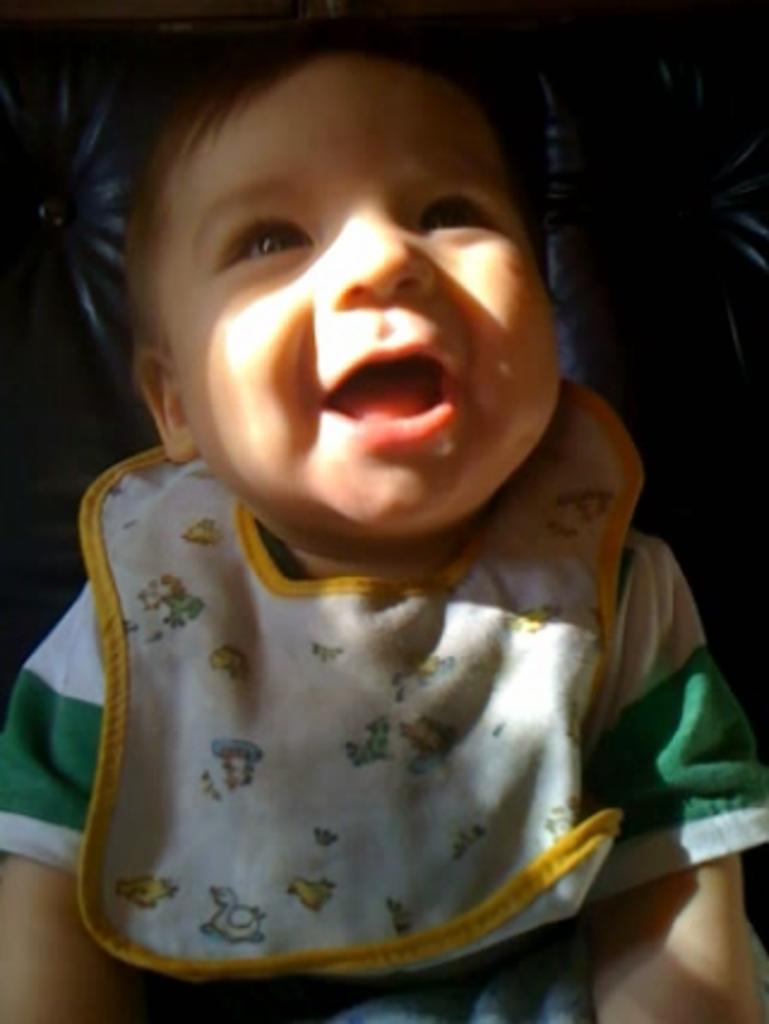How would you summarize this image in a sentence or two? As we can see in the image there is a child wearing green color shirt. 